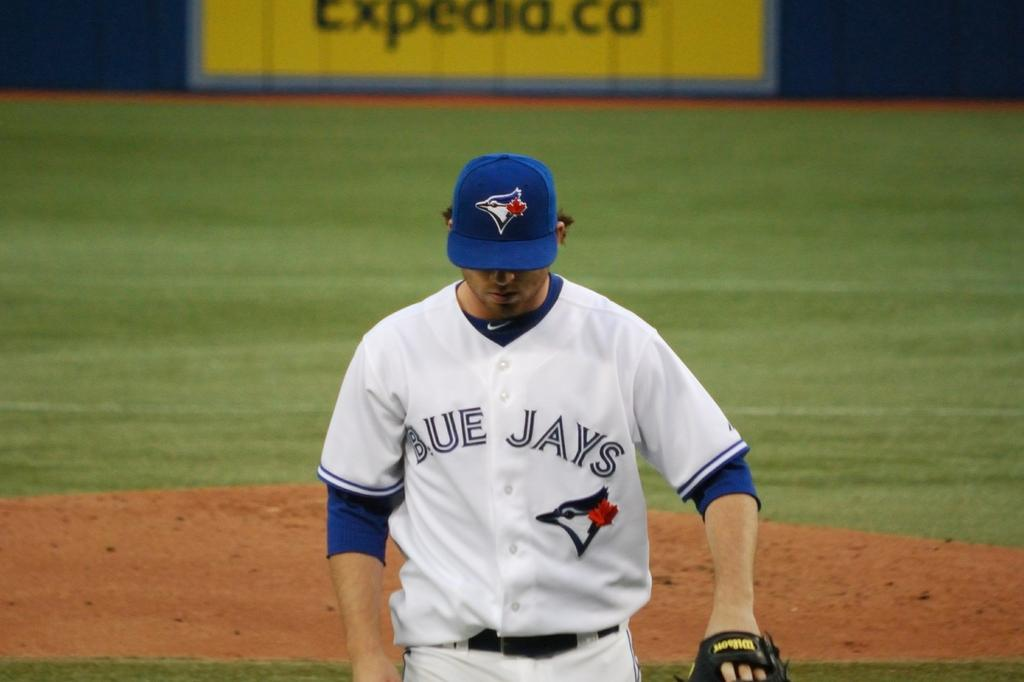Provide a one-sentence caption for the provided image. A professional baseball player for the Blue Jays deeply concentrating. 